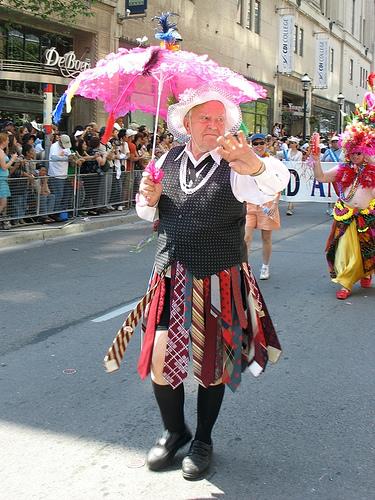Is the old man with the pink umbrella holding anything in his left hand?
Answer briefly. No. Where is the man at?
Keep it brief. Parade. What is the man's skirt made of?
Answer briefly. Ties. 